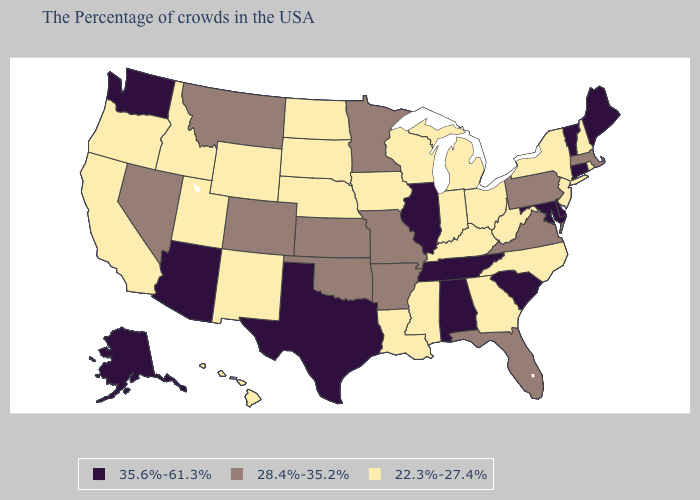Which states have the highest value in the USA?
Keep it brief. Maine, Vermont, Connecticut, Delaware, Maryland, South Carolina, Alabama, Tennessee, Illinois, Texas, Arizona, Washington, Alaska. Does Ohio have the lowest value in the USA?
Concise answer only. Yes. Which states hav the highest value in the West?
Quick response, please. Arizona, Washington, Alaska. Which states have the lowest value in the South?
Concise answer only. North Carolina, West Virginia, Georgia, Kentucky, Mississippi, Louisiana. What is the value of Nebraska?
Write a very short answer. 22.3%-27.4%. Does the first symbol in the legend represent the smallest category?
Keep it brief. No. Does North Carolina have a higher value than Utah?
Short answer required. No. What is the highest value in the MidWest ?
Give a very brief answer. 35.6%-61.3%. What is the lowest value in the USA?
Give a very brief answer. 22.3%-27.4%. What is the value of Pennsylvania?
Keep it brief. 28.4%-35.2%. Name the states that have a value in the range 28.4%-35.2%?
Be succinct. Massachusetts, Pennsylvania, Virginia, Florida, Missouri, Arkansas, Minnesota, Kansas, Oklahoma, Colorado, Montana, Nevada. Among the states that border Kentucky , which have the highest value?
Be succinct. Tennessee, Illinois. Which states have the lowest value in the USA?
Answer briefly. Rhode Island, New Hampshire, New York, New Jersey, North Carolina, West Virginia, Ohio, Georgia, Michigan, Kentucky, Indiana, Wisconsin, Mississippi, Louisiana, Iowa, Nebraska, South Dakota, North Dakota, Wyoming, New Mexico, Utah, Idaho, California, Oregon, Hawaii. What is the value of Montana?
Keep it brief. 28.4%-35.2%. Name the states that have a value in the range 35.6%-61.3%?
Give a very brief answer. Maine, Vermont, Connecticut, Delaware, Maryland, South Carolina, Alabama, Tennessee, Illinois, Texas, Arizona, Washington, Alaska. 